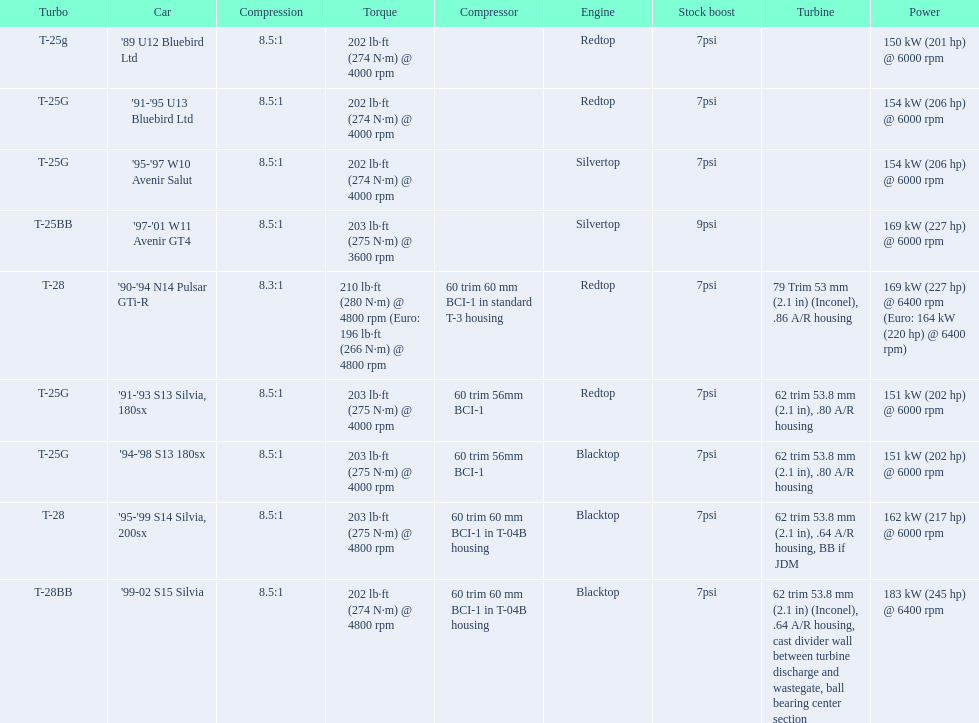What are the psi's? 7psi, 7psi, 7psi, 9psi, 7psi, 7psi, 7psi, 7psi, 7psi. What are the number(s) greater than 7? 9psi. Which car has that number? '97-'01 W11 Avenir GT4. Parse the full table. {'header': ['Turbo', 'Car', 'Compression', 'Torque', 'Compressor', 'Engine', 'Stock boost', 'Turbine', 'Power'], 'rows': [['T-25g', "'89 U12 Bluebird Ltd", '8.5:1', '202\xa0lb·ft (274\xa0N·m) @ 4000 rpm', '', 'Redtop', '7psi', '', '150\xa0kW (201\xa0hp) @ 6000 rpm'], ['T-25G', "'91-'95 U13 Bluebird Ltd", '8.5:1', '202\xa0lb·ft (274\xa0N·m) @ 4000 rpm', '', 'Redtop', '7psi', '', '154\xa0kW (206\xa0hp) @ 6000 rpm'], ['T-25G', "'95-'97 W10 Avenir Salut", '8.5:1', '202\xa0lb·ft (274\xa0N·m) @ 4000 rpm', '', 'Silvertop', '7psi', '', '154\xa0kW (206\xa0hp) @ 6000 rpm'], ['T-25BB', "'97-'01 W11 Avenir GT4", '8.5:1', '203\xa0lb·ft (275\xa0N·m) @ 3600 rpm', '', 'Silvertop', '9psi', '', '169\xa0kW (227\xa0hp) @ 6000 rpm'], ['T-28', "'90-'94 N14 Pulsar GTi-R", '8.3:1', '210\xa0lb·ft (280\xa0N·m) @ 4800 rpm (Euro: 196\xa0lb·ft (266\xa0N·m) @ 4800 rpm', '60 trim 60\xa0mm BCI-1 in standard T-3 housing', 'Redtop', '7psi', '79 Trim 53\xa0mm (2.1\xa0in) (Inconel), .86 A/R housing', '169\xa0kW (227\xa0hp) @ 6400 rpm (Euro: 164\xa0kW (220\xa0hp) @ 6400 rpm)'], ['T-25G', "'91-'93 S13 Silvia, 180sx", '8.5:1', '203\xa0lb·ft (275\xa0N·m) @ 4000 rpm', '60 trim 56mm BCI-1', 'Redtop', '7psi', '62 trim 53.8\xa0mm (2.1\xa0in), .80 A/R housing', '151\xa0kW (202\xa0hp) @ 6000 rpm'], ['T-25G', "'94-'98 S13 180sx", '8.5:1', '203\xa0lb·ft (275\xa0N·m) @ 4000 rpm', '60 trim 56mm BCI-1', 'Blacktop', '7psi', '62 trim 53.8\xa0mm (2.1\xa0in), .80 A/R housing', '151\xa0kW (202\xa0hp) @ 6000 rpm'], ['T-28', "'95-'99 S14 Silvia, 200sx", '8.5:1', '203\xa0lb·ft (275\xa0N·m) @ 4800 rpm', '60 trim 60\xa0mm BCI-1 in T-04B housing', 'Blacktop', '7psi', '62 trim 53.8\xa0mm (2.1\xa0in), .64 A/R housing, BB if JDM', '162\xa0kW (217\xa0hp) @ 6000 rpm'], ['T-28BB', "'99-02 S15 Silvia", '8.5:1', '202\xa0lb·ft (274\xa0N·m) @ 4800 rpm', '60 trim 60\xa0mm BCI-1 in T-04B housing', 'Blacktop', '7psi', '62 trim 53.8\xa0mm (2.1\xa0in) (Inconel), .64 A/R housing, cast divider wall between turbine discharge and wastegate, ball bearing center section', '183\xa0kW (245\xa0hp) @ 6400 rpm']]} 